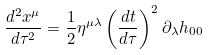<formula> <loc_0><loc_0><loc_500><loc_500>\frac { d ^ { 2 } x ^ { \mu } } { d \tau ^ { 2 } } = \frac { 1 } { 2 } \eta ^ { \mu \lambda } \left ( \frac { d t } { d \tau } \right ) ^ { 2 } \partial _ { \lambda } h _ { 0 0 }</formula> 